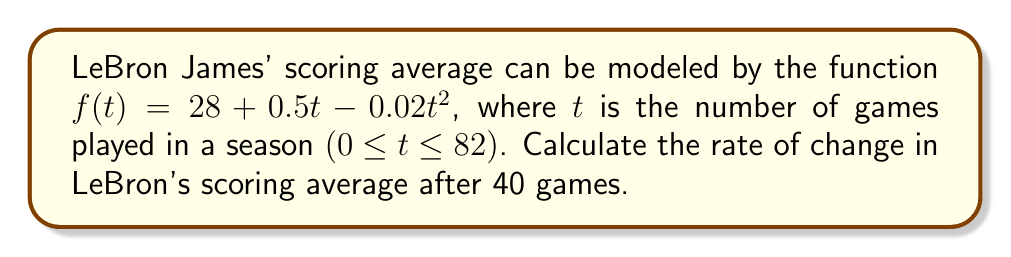Could you help me with this problem? To find the rate of change in LeBron's scoring average after 40 games, we need to calculate the derivative of the function $f(t)$ and evaluate it at $t = 40$.

Step 1: Find the derivative of $f(t)$.
$$f(t) = 28 + 0.5t - 0.02t^2$$
$$f'(t) = 0.5 - 0.04t$$

Step 2: Evaluate $f'(t)$ at $t = 40$.
$$f'(40) = 0.5 - 0.04(40)$$
$$f'(40) = 0.5 - 1.6$$
$$f'(40) = -1.1$$

The negative value indicates that LeBron's scoring average is decreasing at this point in the season.
Answer: $-1.1$ points per game 